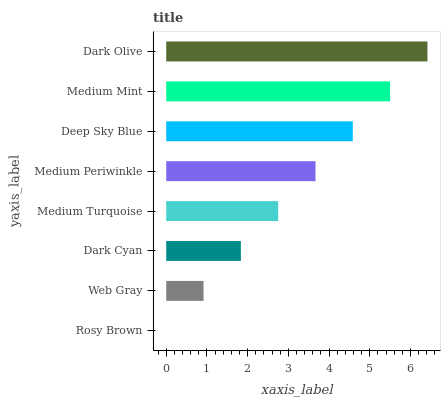Is Rosy Brown the minimum?
Answer yes or no. Yes. Is Dark Olive the maximum?
Answer yes or no. Yes. Is Web Gray the minimum?
Answer yes or no. No. Is Web Gray the maximum?
Answer yes or no. No. Is Web Gray greater than Rosy Brown?
Answer yes or no. Yes. Is Rosy Brown less than Web Gray?
Answer yes or no. Yes. Is Rosy Brown greater than Web Gray?
Answer yes or no. No. Is Web Gray less than Rosy Brown?
Answer yes or no. No. Is Medium Periwinkle the high median?
Answer yes or no. Yes. Is Medium Turquoise the low median?
Answer yes or no. Yes. Is Dark Cyan the high median?
Answer yes or no. No. Is Rosy Brown the low median?
Answer yes or no. No. 